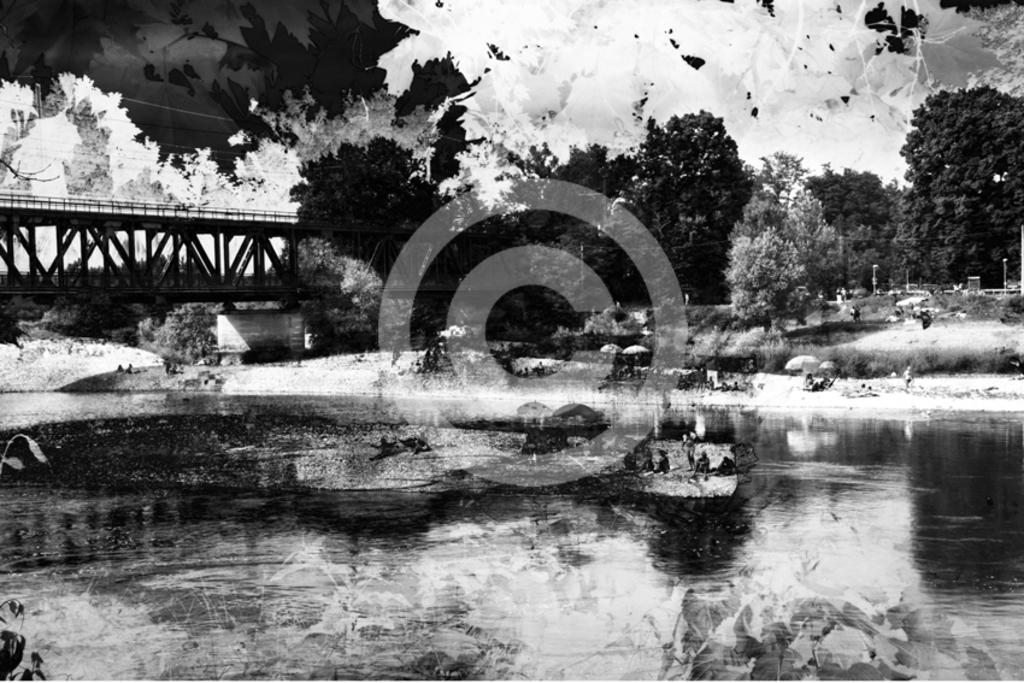What is the color scheme of the image? The image is black and white. What can be seen on the land in the image? There are people on the land in the image. What is visible at the bottom of the image? There is water visible at the bottom of the image. What structure is located on the left side of the image? There is a bridge on the left side of the image. What type of vegetation is present in the background of the image? The background of the image includes plants and trees on the land. What type of comb is being used by the daughter in the image? There is no daughter or comb present in the image. What type of thing is being held by the people in the image? The provided facts do not mention any specific objects being held by the people in the image. 